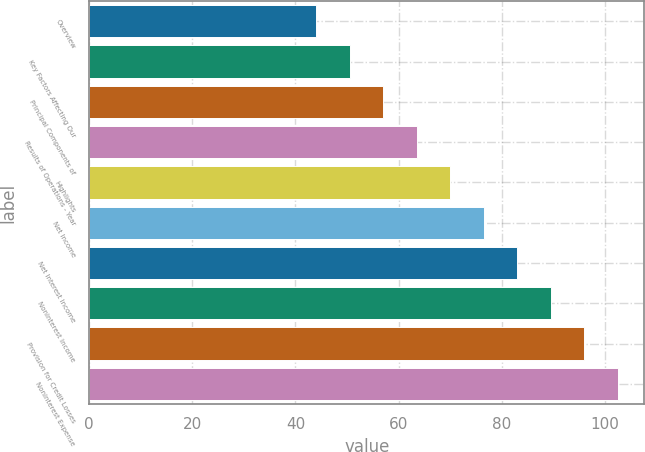<chart> <loc_0><loc_0><loc_500><loc_500><bar_chart><fcel>Overview<fcel>Key Factors Affecting Our<fcel>Principal Components of<fcel>Results of Operations - Year<fcel>Highlights<fcel>Net Income<fcel>Net Interest Income<fcel>Noninterest Income<fcel>Provision for Credit Losses<fcel>Noninterest Expense<nl><fcel>44<fcel>50.5<fcel>57<fcel>63.5<fcel>70<fcel>76.5<fcel>83<fcel>89.5<fcel>96<fcel>102.5<nl></chart> 